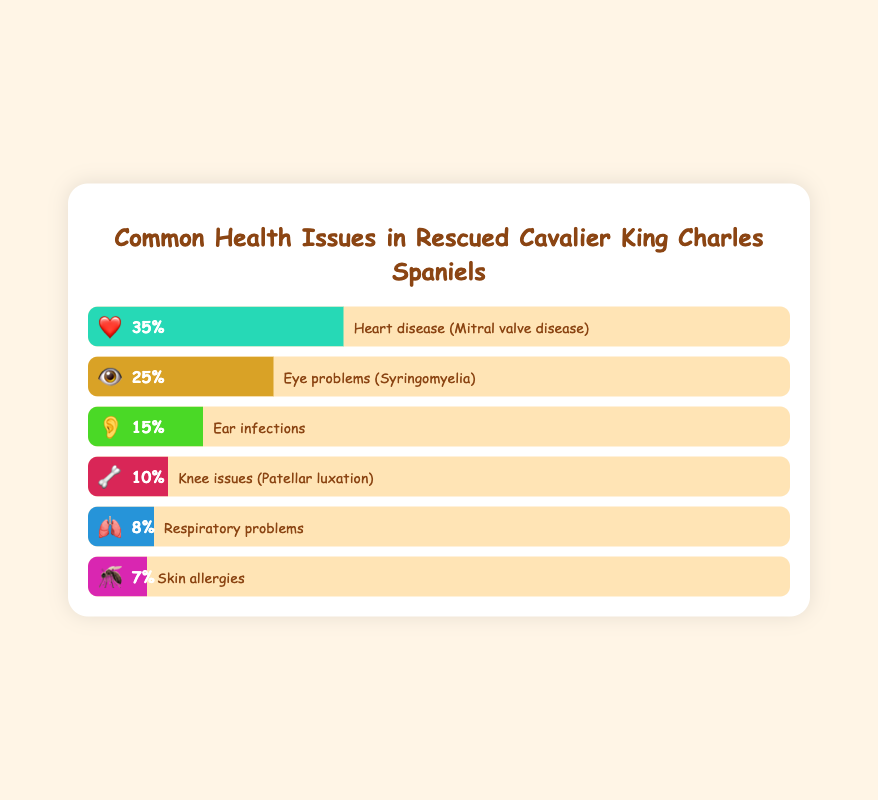What percentage of rescued Cavalier King Charles Spaniels have heart disease? The figure shows that heart disease (Mitral valve disease) is represented by a heart emoji with a percentage note. By reading the percentage next to the heart emoji, we see it's stated as 35%.
Answer: 35% Which health issue is the second most common among rescued Cavalier King Charles Spaniels? To identify the second most common health issue, we examine the percentages and look for the second highest value. The heart disease is at 35%, followed by eye problems with a percentage of 25%.
Answer: Eye problems (Syringomyelia) How does the percentage of dogs with knee issues compare to those with ear infections? The percentage of dogs with knee issues (Patellar luxation) is 10%, and the percentage with ear infections is 15%. By comparing these two percentages, ear infections are higher than knee issues.
Answer: Ear infections are higher What is the combined percentage of dogs with skin allergies and respiratory problems? Skin allergies account for 7%, and respiratory problems account for 8%. Adding these two percentages together yields 7% + 8% = 15%.
Answer: 15% Which emoji corresponds to the most common health problem among the dogs? The figure lists heart disease as the most common health issue at 35%. The associated emoji for heart disease is a heart (❤️).
Answer: ❤️ What percentage of dogs have ear infections, and how does this rank among all listed health issues? The ear infections percentage is given as 15%. Ranking the percentages, ear infections fall behind heart disease and eye problems, making it the third most common issue.
Answer: 15%, third Calculate the difference in percentages between the most and least common health issues. The most common health issue is heart disease at 35%, and the least common is skin allergies at 7%. The difference is calculated as 35% - 7% = 28%.
Answer: 28% Are there fewer dogs with respiratory problems than knee issues, and by how much? Respiratory problems are at 8%, and knee issues are at 10%. The difference is 10% - 8% = 2%, indicating that respiratory problems are fewer by 2%.
Answer: Yes, by 2% Which health issue, represented by an eyeball emoji, affects rescued Cavalier King Charles Spaniels? The eyeball emoji (👁️) in the figure corresponds to eye problems (Syringomyelia), affecting 25% of the dogs.
Answer: Eye problems (Syringomyelia) What percentage of dogs suffer from health issues related to the ears? The figure indicates ear infections, with an ear emoji (👂), affecting 15% of the rescued dogs.
Answer: 15% 